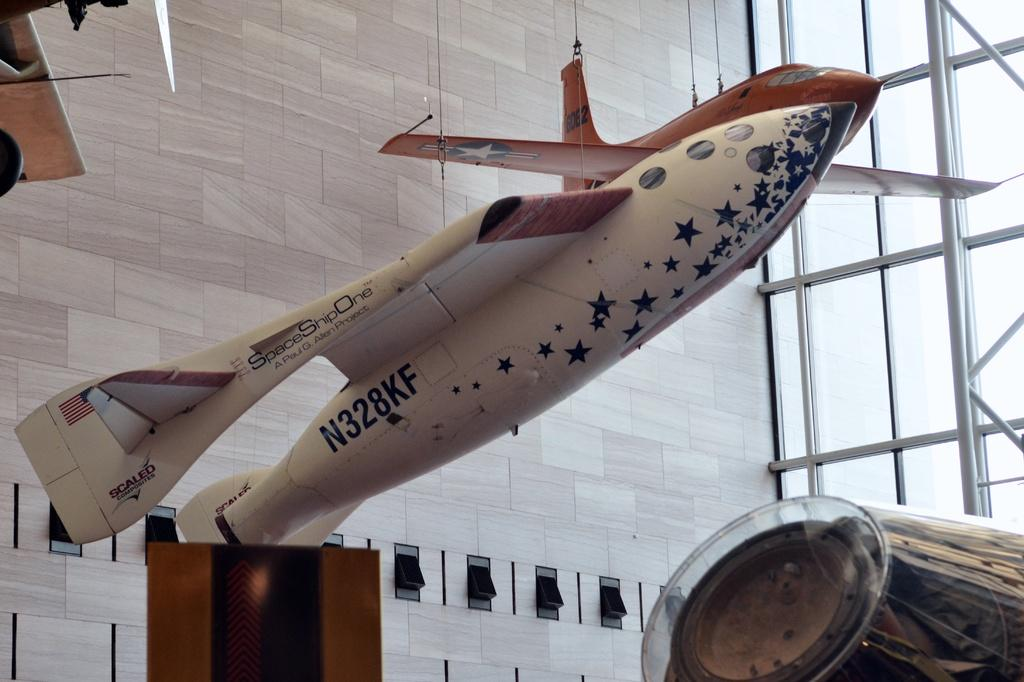Provide a one-sentence caption for the provided image. Spaceshipone airplane that is up in the air for decorations in a building. 